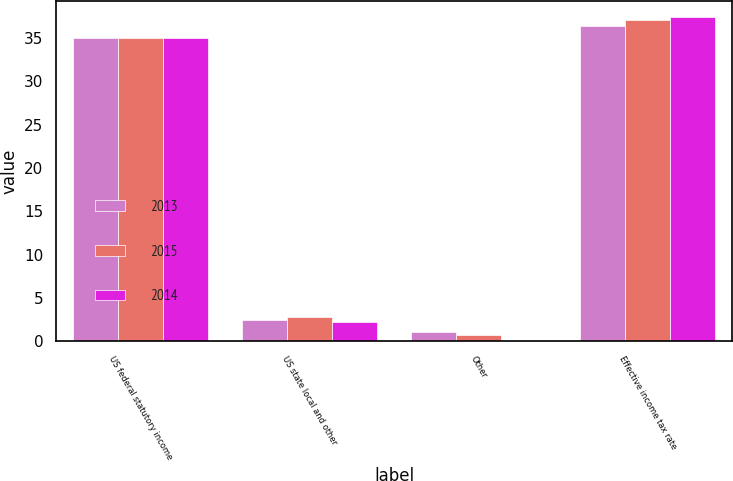Convert chart. <chart><loc_0><loc_0><loc_500><loc_500><stacked_bar_chart><ecel><fcel>US federal statutory income<fcel>US state local and other<fcel>Other<fcel>Effective income tax rate<nl><fcel>2013<fcel>35<fcel>2.5<fcel>1.1<fcel>36.4<nl><fcel>2015<fcel>35<fcel>2.8<fcel>0.7<fcel>37.1<nl><fcel>2014<fcel>35<fcel>2.2<fcel>0.2<fcel>37.4<nl></chart> 